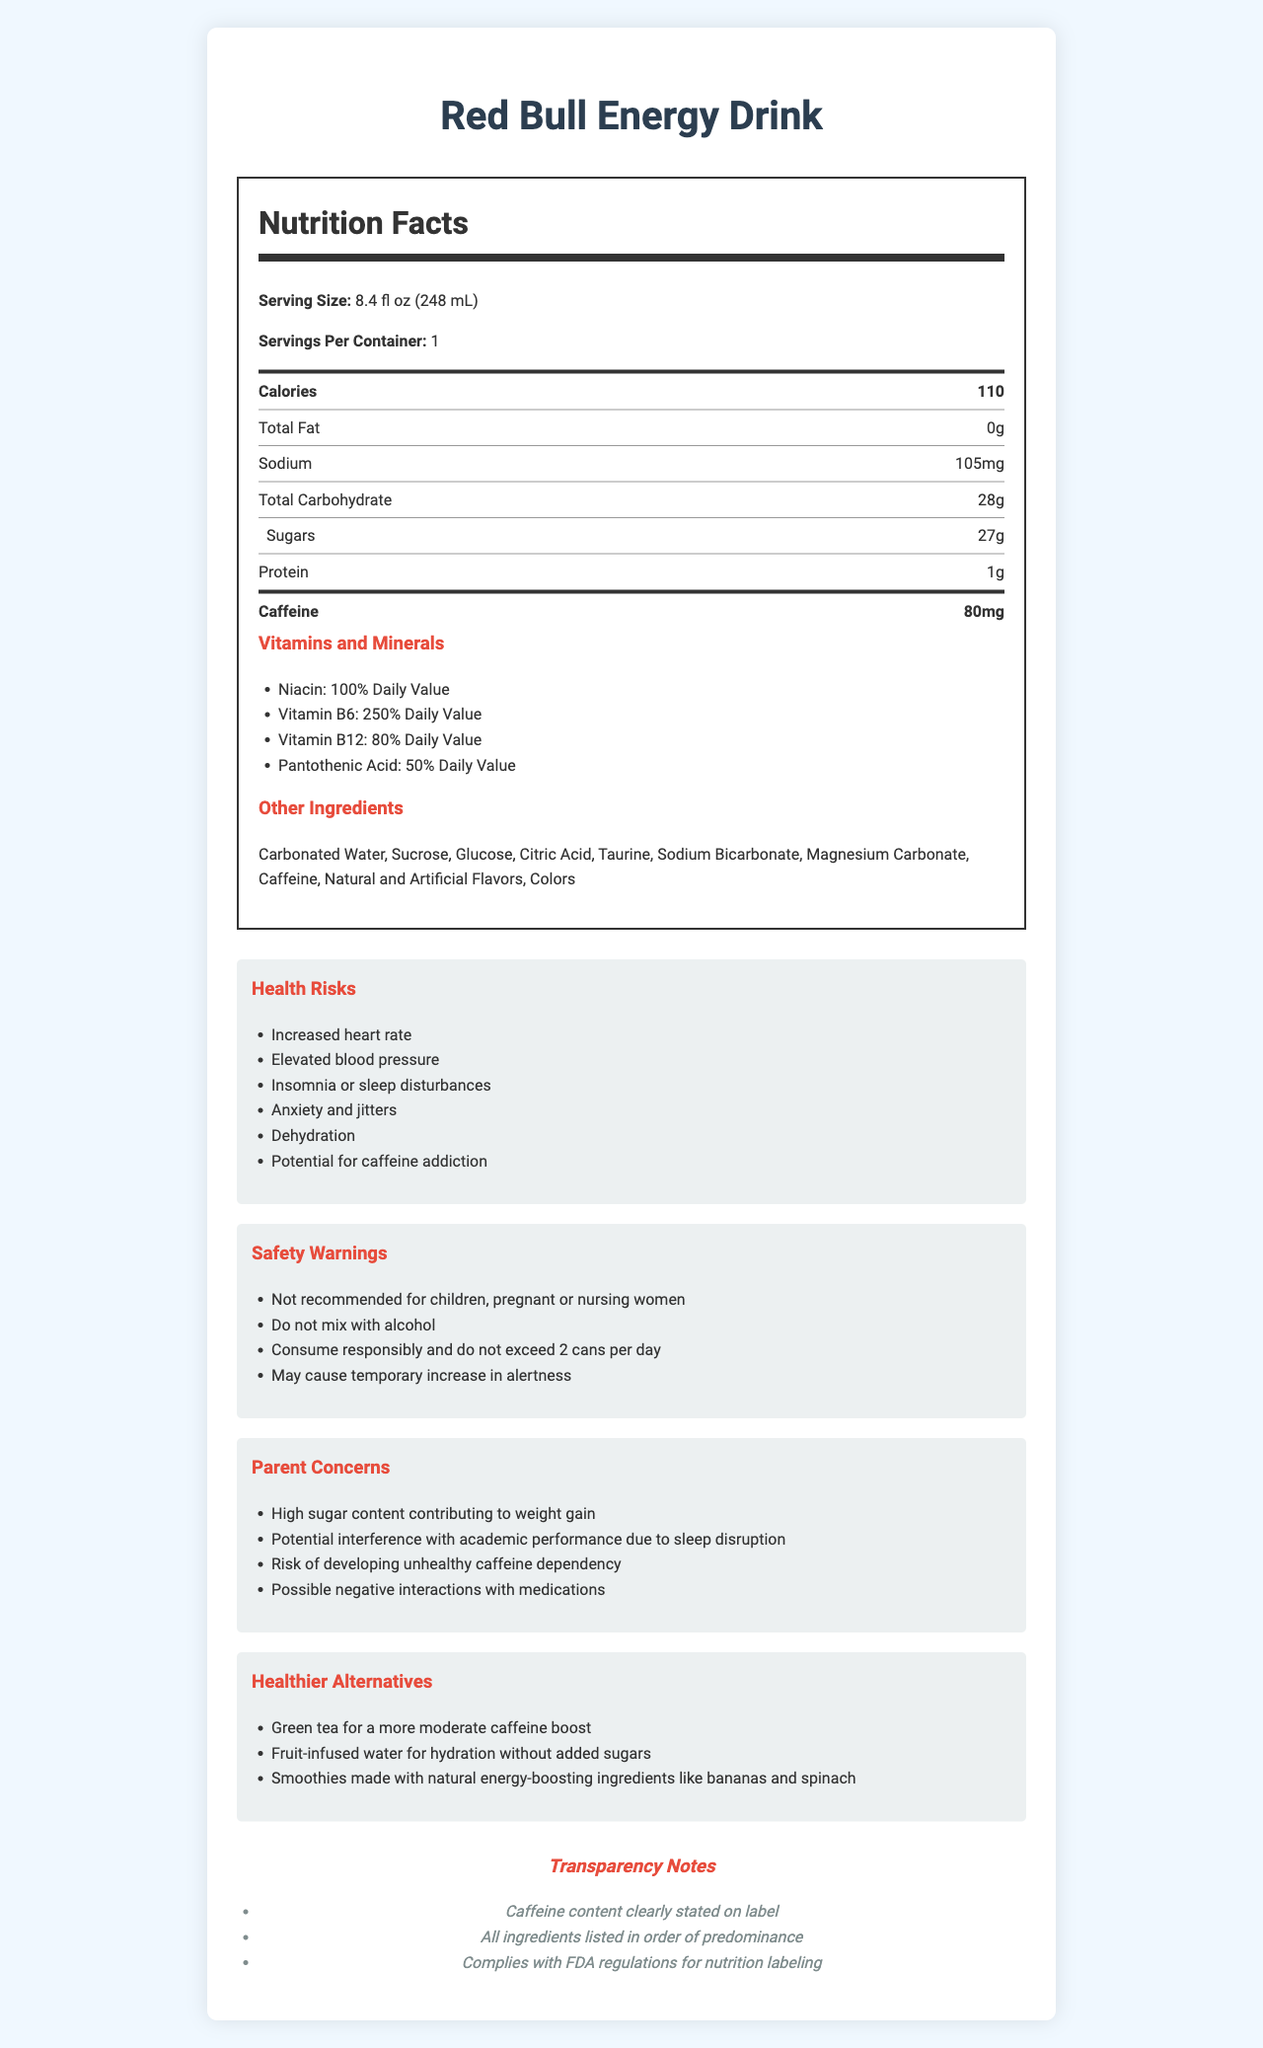what is the serving size for Red Bull Energy Drink? The serving size is stated in the "Nutrition Facts" section.
Answer: 8.4 fl oz (248 mL) how much caffeine is in one can of Red Bull Energy Drink? The caffeine content is listed in the "Nutrition Facts" section of the label.
Answer: 80mg what are the main health risks associated with consuming Red Bull Energy Drink? These health risks are listed under the "Health Risks" section.
Answer: Increased heart rate, Elevated blood pressure, Insomnia or sleep disturbances, Anxiety and jitters, Dehydration, Potential for caffeine addiction how many grams of sugar are in one serving of Red Bull Energy Drink? The sugar content is listed under "Total Carbohydrate" in the "Nutrition Facts" section.
Answer: 27g which vitamin is present at the highest percentage of Daily Value in Red Bull Energy Drink? The percentage of Daily Value for each vitamin is listed in the "Vitamins and Minerals" section.
Answer: Vitamin B6 at 250% Daily Value what is the recommended maximum number of cans of Red Bull Energy Drink to consume per day according to the safety warnings? The safety warning section advises not to exceed 2 cans per day.
Answer: 2 cans per day what is a healthier alternative to Red Bull Energy Drink for a moderate caffeine boost? A. Green tea B. Fruit-infused water C. Smoothies The "Healthier Alternatives" section lists green tea as an option for a more moderate caffeine boost.
Answer: A. Green tea which of the following is a potential danger of mixing Red Bull Energy Drink with alcohol? A. Increased heart rate B. Elevated blood pressure C. Do not mix with alcohol The safety warnings specifically state not to mix with alcohol.
Answer: C. Do not mix with alcohol is Red Bull Energy Drink recommended for children? The safety warnings state that the drink is not recommended for children.
Answer: No describe the main idea of the document The document covers various aspects of the energy drink, including its nutritional content, health risks, and safety warnings, as well as parent concerns and healthier alternatives.
Answer: The document provides detailed nutrition facts, health risks, safety warnings, parent concerns, and healthier alternatives related to Red Bull Energy Drink, with an emphasis on transparency of ingredients and potential health implications. how does the sugar content in Red Bull Energy Drink compare to the total carbohydrate content? The "Nutrition Facts" section shows that sugars make up almost all of the total carbohydrates in the drink (27g sugars out of 28g total carbohydrates).
Answer: The sugar content is 27g, which constitutes most of the total carbohydrate content of 28g. who regulates the nutrition labeling for Red Bull Energy Drink? The transparency notes mention compliance with FDA regulations for nutrition labeling.
Answer: The FDA can we determine how many cans of Red Bull Energy Drink a person can safely consume over a week directly from this document? The document only provides a daily limit of 2 cans, but it does not provide specific weekly guidelines or consider individual variations in tolerance.
Answer: Not enough information 